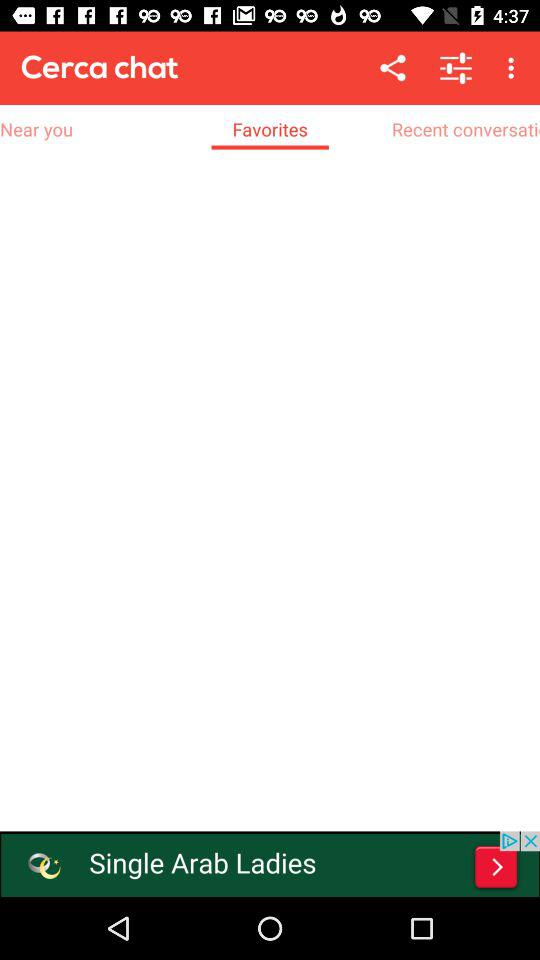What is the name of the application? The name of the application is "Cerca chat". 